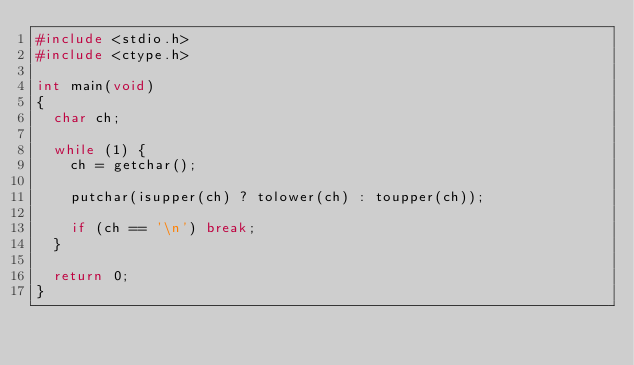<code> <loc_0><loc_0><loc_500><loc_500><_C_>#include <stdio.h>
#include <ctype.h>

int main(void)
{
	char ch;

	while (1) {
		ch = getchar();

		putchar(isupper(ch) ? tolower(ch) : toupper(ch));

		if (ch == '\n')	break;
	}

	return 0;
}</code> 